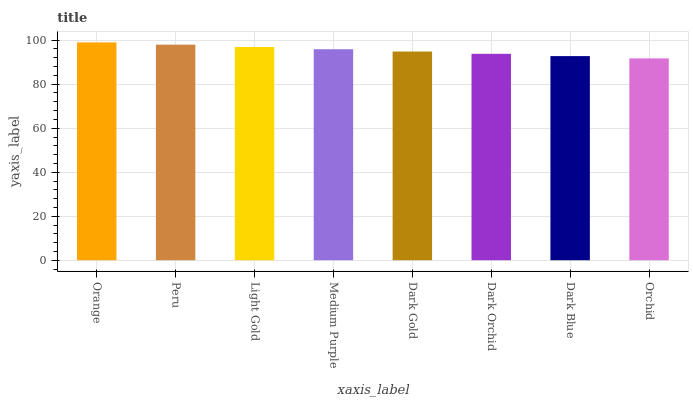Is Orchid the minimum?
Answer yes or no. Yes. Is Orange the maximum?
Answer yes or no. Yes. Is Peru the minimum?
Answer yes or no. No. Is Peru the maximum?
Answer yes or no. No. Is Orange greater than Peru?
Answer yes or no. Yes. Is Peru less than Orange?
Answer yes or no. Yes. Is Peru greater than Orange?
Answer yes or no. No. Is Orange less than Peru?
Answer yes or no. No. Is Medium Purple the high median?
Answer yes or no. Yes. Is Dark Gold the low median?
Answer yes or no. Yes. Is Dark Blue the high median?
Answer yes or no. No. Is Dark Orchid the low median?
Answer yes or no. No. 